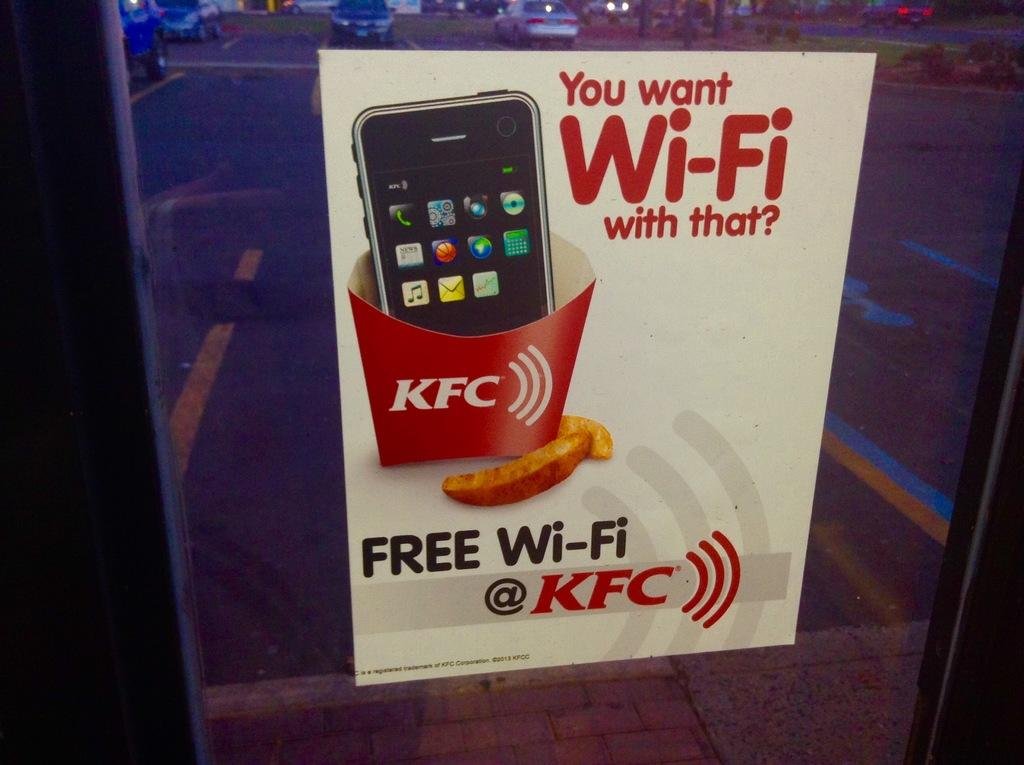<image>
Write a terse but informative summary of the picture. A poster in a window promotes free Wi-Fi at KFC. 